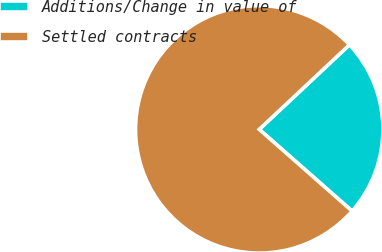Convert chart to OTSL. <chart><loc_0><loc_0><loc_500><loc_500><pie_chart><fcel>Additions/Change in value of<fcel>Settled contracts<nl><fcel>23.47%<fcel>76.53%<nl></chart> 